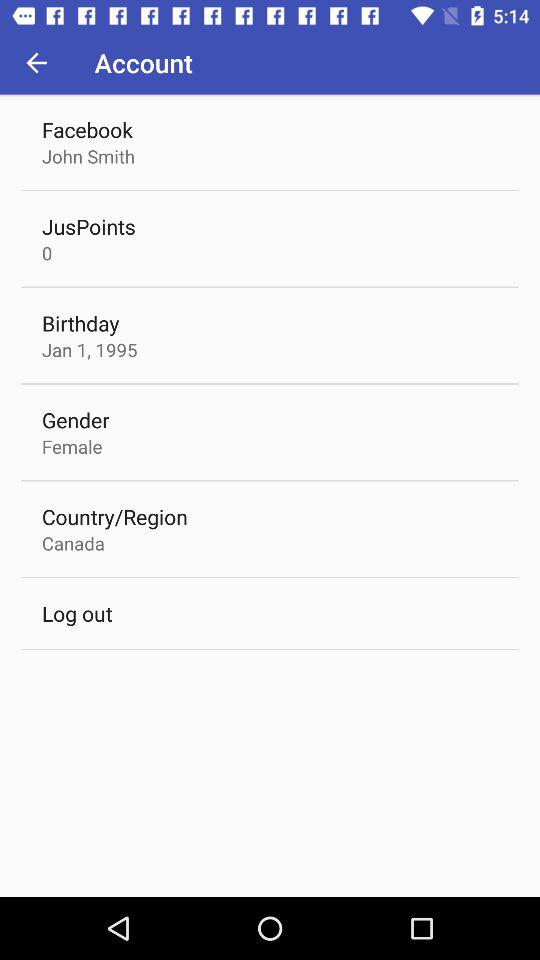How many numbers are in JusPoints? The number is 0. 